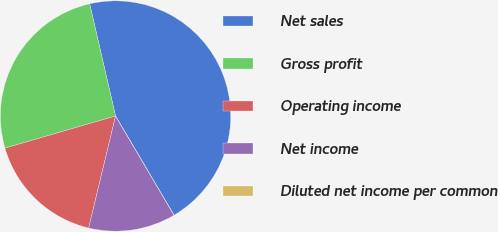Convert chart. <chart><loc_0><loc_0><loc_500><loc_500><pie_chart><fcel>Net sales<fcel>Gross profit<fcel>Operating income<fcel>Net income<fcel>Diluted net income per common<nl><fcel>45.13%<fcel>25.89%<fcel>16.75%<fcel>12.23%<fcel>0.0%<nl></chart> 